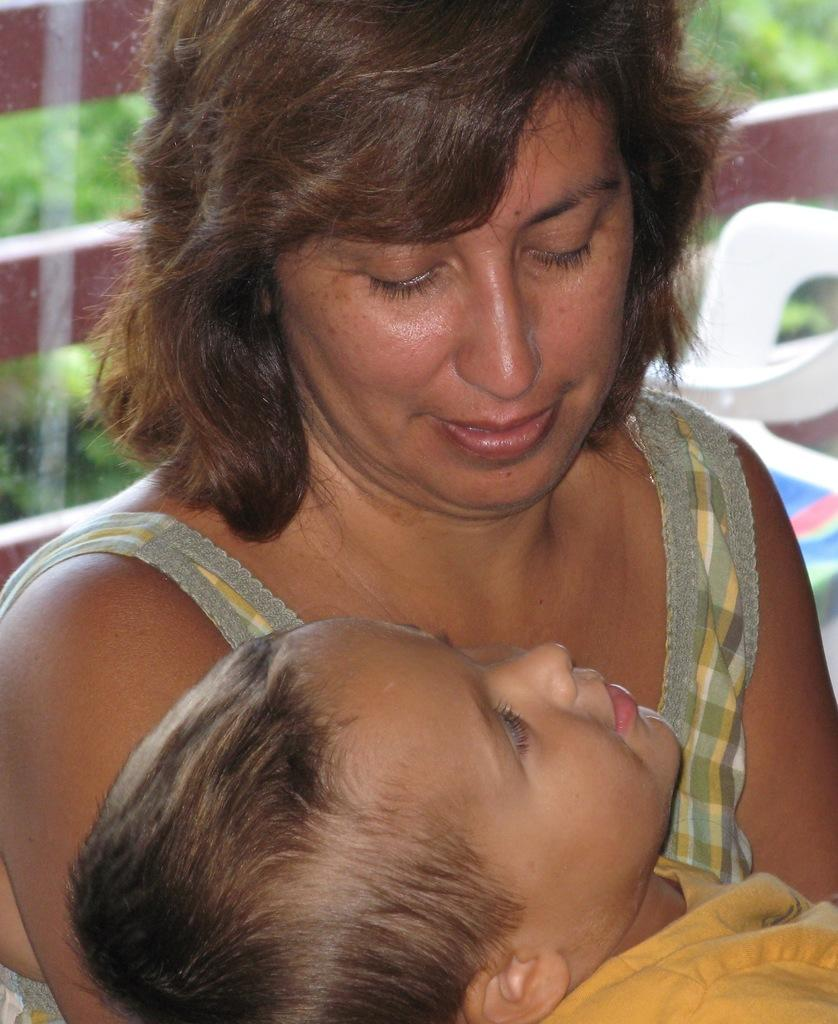Who are the people in the image? There is a woman and a boy in the image. What is the woman doing in the image? The woman is looking at the boy. Can you describe the background of the image? The background of the image is blurred. What type of ink is being used by the woman in the image? There is no ink present in the image, as it features a woman looking at a boy with a blurred background. 